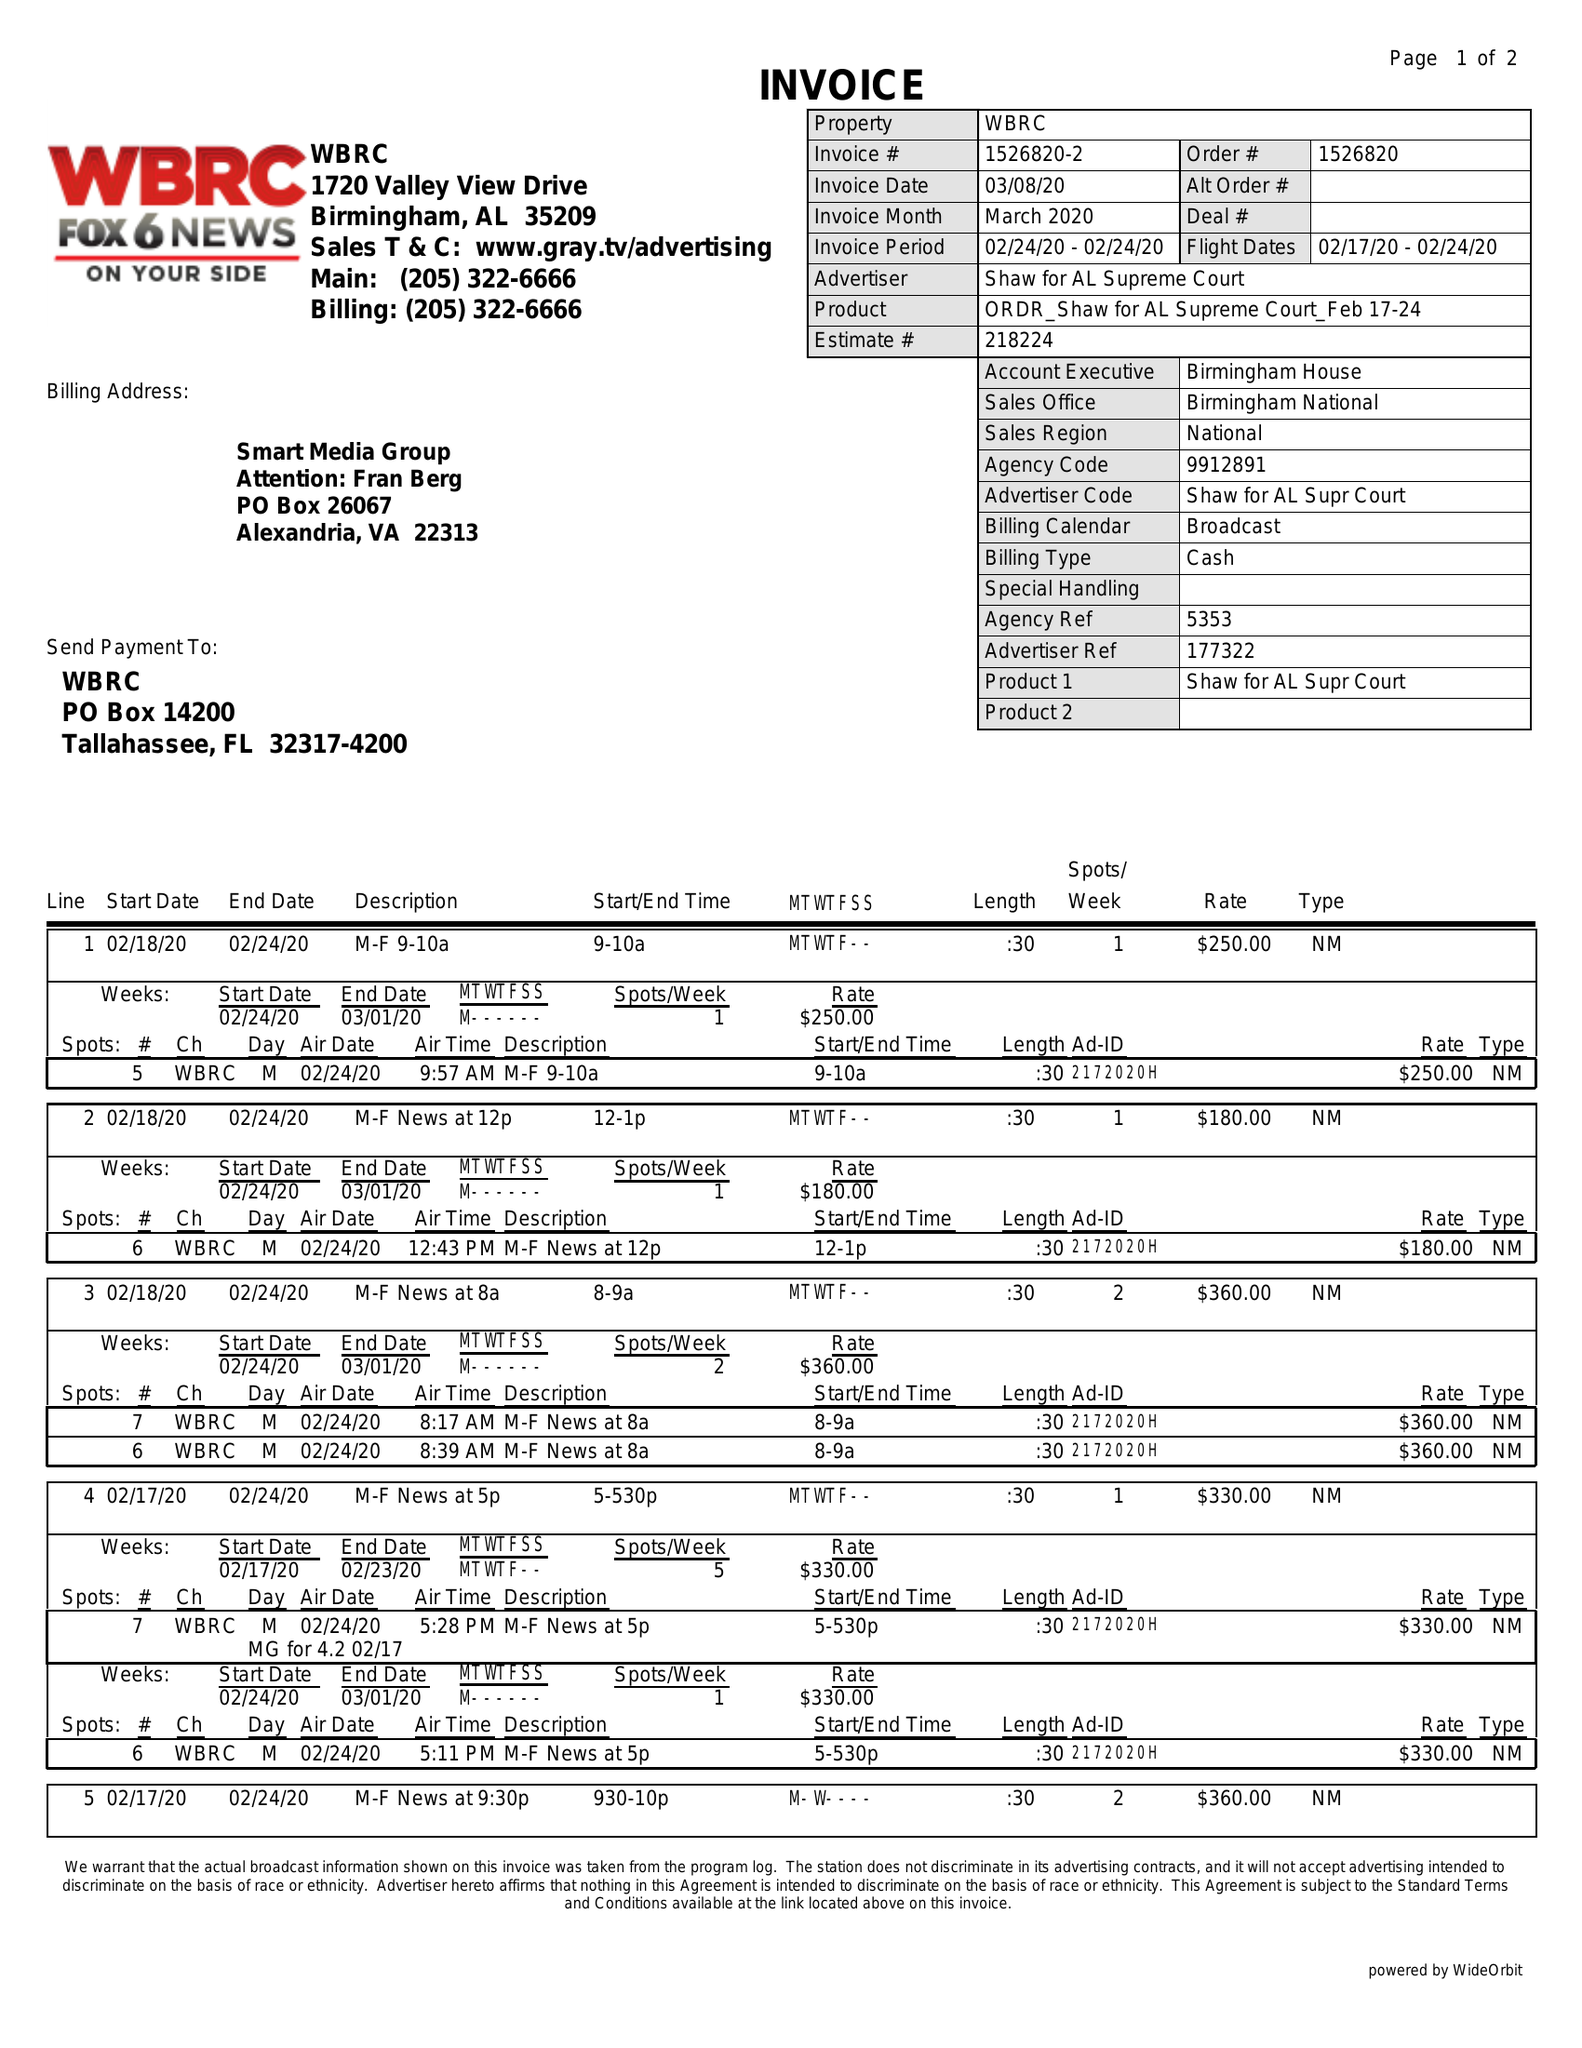What is the value for the gross_amount?
Answer the question using a single word or phrase. 7450.00 